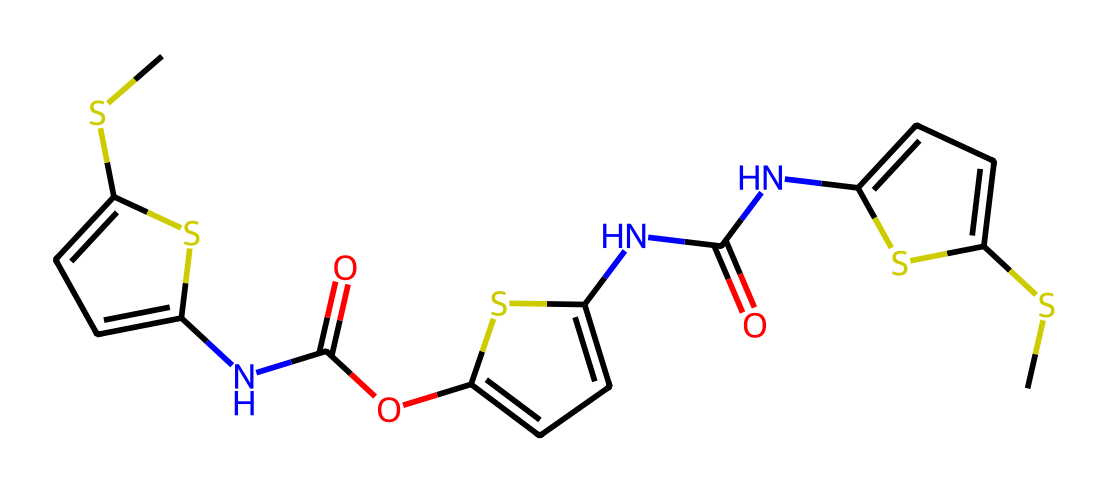What is the total number of nitrogen atoms in thiophanate-methyl? By examining the SMILES structure, we can identify nitrogen atoms represented by 'N'. Counting the occurrences of 'N', we find there are three nitrogen atoms in total.
Answer: 3 What functional groups are present in thiophanate-methyl? The structure includes amide (-C(=O)N-) and thioether (-S-) functional groups. Identifying the specific connections in the SMILES notation confirms these groups.
Answer: amide, thioether How many sulfur atoms are present in the compound? In the SMILES representation, the letter 'S' indicates sulfur atoms. Upon review, there are two 'S' present in the structure, confirming the count.
Answer: 2 What is the highest oxidation state of sulfur in thiophanate-methyl? The oxidation state of sulfur can be inferred from its bonding environment. In the thioether configuration, sulfur has a lower oxidation state, while it usually has a higher oxidation state in sulfonyl configurations. In this case, the highest oxidation state appears to be +6.
Answer: +6 How does thiophanate-methyl function as a fungicide? Thiophanate-methyl works by inhibiting fungal cell division and growth through interference with mitotic processes. This can be deduced by understanding the interactions of similar fungicides and their components in their structures.
Answer: inhibiting cell division What is the molecular weight of thiophanate-methyl? To calculate the molecular weight, sum the weights of all atoms present in the structure based on the counts deduced from the SMILES. The total from the calculation comes out to be approximately 295.35 g/mol.
Answer: 295.35 g/mol 